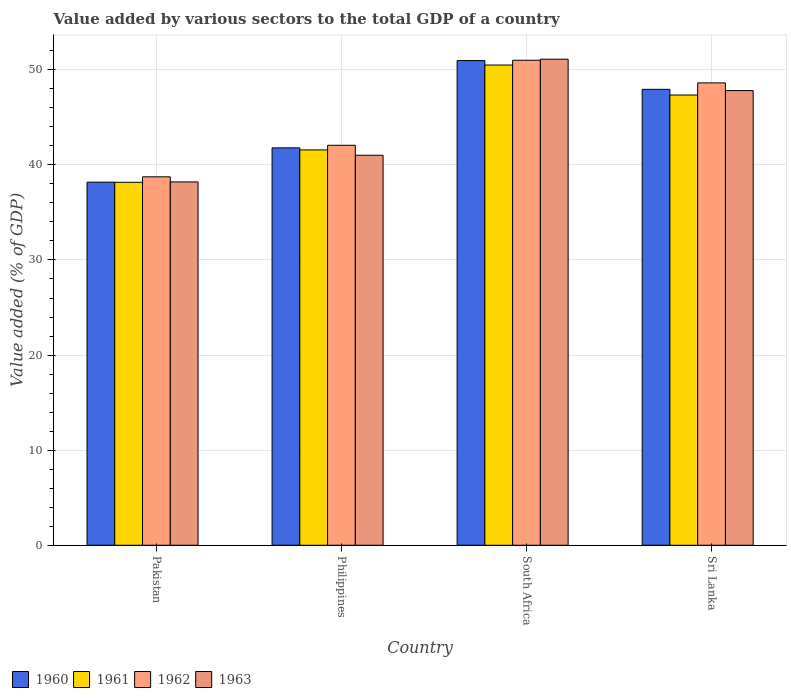How many different coloured bars are there?
Offer a very short reply. 4. Are the number of bars per tick equal to the number of legend labels?
Provide a succinct answer. Yes. Are the number of bars on each tick of the X-axis equal?
Keep it short and to the point. Yes. How many bars are there on the 1st tick from the right?
Provide a succinct answer. 4. What is the label of the 1st group of bars from the left?
Give a very brief answer. Pakistan. What is the value added by various sectors to the total GDP in 1961 in Sri Lanka?
Your response must be concise. 47.35. Across all countries, what is the maximum value added by various sectors to the total GDP in 1963?
Offer a very short reply. 51.12. Across all countries, what is the minimum value added by various sectors to the total GDP in 1960?
Ensure brevity in your answer.  38.18. In which country was the value added by various sectors to the total GDP in 1961 maximum?
Your answer should be compact. South Africa. In which country was the value added by various sectors to the total GDP in 1961 minimum?
Keep it short and to the point. Pakistan. What is the total value added by various sectors to the total GDP in 1962 in the graph?
Offer a very short reply. 180.44. What is the difference between the value added by various sectors to the total GDP in 1961 in South Africa and that in Sri Lanka?
Offer a terse response. 3.16. What is the difference between the value added by various sectors to the total GDP in 1962 in Philippines and the value added by various sectors to the total GDP in 1963 in Pakistan?
Ensure brevity in your answer.  3.85. What is the average value added by various sectors to the total GDP in 1962 per country?
Offer a very short reply. 45.11. What is the difference between the value added by various sectors to the total GDP of/in 1961 and value added by various sectors to the total GDP of/in 1963 in Pakistan?
Your answer should be very brief. -0.04. What is the ratio of the value added by various sectors to the total GDP in 1960 in Pakistan to that in Philippines?
Provide a short and direct response. 0.91. What is the difference between the highest and the second highest value added by various sectors to the total GDP in 1962?
Your answer should be compact. 6.56. What is the difference between the highest and the lowest value added by various sectors to the total GDP in 1963?
Offer a terse response. 12.91. In how many countries, is the value added by various sectors to the total GDP in 1962 greater than the average value added by various sectors to the total GDP in 1962 taken over all countries?
Offer a very short reply. 2. Is the sum of the value added by various sectors to the total GDP in 1960 in Pakistan and Philippines greater than the maximum value added by various sectors to the total GDP in 1963 across all countries?
Keep it short and to the point. Yes. Is it the case that in every country, the sum of the value added by various sectors to the total GDP in 1961 and value added by various sectors to the total GDP in 1963 is greater than the sum of value added by various sectors to the total GDP in 1960 and value added by various sectors to the total GDP in 1962?
Make the answer very short. No. What does the 4th bar from the right in Philippines represents?
Your response must be concise. 1960. Are all the bars in the graph horizontal?
Your answer should be very brief. No. What is the difference between two consecutive major ticks on the Y-axis?
Make the answer very short. 10. Does the graph contain any zero values?
Provide a short and direct response. No. How many legend labels are there?
Your response must be concise. 4. How are the legend labels stacked?
Make the answer very short. Horizontal. What is the title of the graph?
Keep it short and to the point. Value added by various sectors to the total GDP of a country. Does "1968" appear as one of the legend labels in the graph?
Give a very brief answer. No. What is the label or title of the X-axis?
Offer a very short reply. Country. What is the label or title of the Y-axis?
Make the answer very short. Value added (% of GDP). What is the Value added (% of GDP) in 1960 in Pakistan?
Keep it short and to the point. 38.18. What is the Value added (% of GDP) of 1961 in Pakistan?
Provide a short and direct response. 38.17. What is the Value added (% of GDP) of 1962 in Pakistan?
Offer a terse response. 38.74. What is the Value added (% of GDP) of 1963 in Pakistan?
Offer a terse response. 38.21. What is the Value added (% of GDP) in 1960 in Philippines?
Provide a succinct answer. 41.79. What is the Value added (% of GDP) in 1961 in Philippines?
Provide a succinct answer. 41.57. What is the Value added (% of GDP) in 1962 in Philippines?
Ensure brevity in your answer.  42.06. What is the Value added (% of GDP) of 1963 in Philippines?
Your answer should be very brief. 41.01. What is the Value added (% of GDP) in 1960 in South Africa?
Make the answer very short. 50.97. What is the Value added (% of GDP) of 1961 in South Africa?
Give a very brief answer. 50.5. What is the Value added (% of GDP) of 1962 in South Africa?
Your response must be concise. 51.01. What is the Value added (% of GDP) in 1963 in South Africa?
Provide a succinct answer. 51.12. What is the Value added (% of GDP) in 1960 in Sri Lanka?
Offer a very short reply. 47.95. What is the Value added (% of GDP) in 1961 in Sri Lanka?
Make the answer very short. 47.35. What is the Value added (% of GDP) in 1962 in Sri Lanka?
Give a very brief answer. 48.62. What is the Value added (% of GDP) in 1963 in Sri Lanka?
Your response must be concise. 47.82. Across all countries, what is the maximum Value added (% of GDP) in 1960?
Offer a terse response. 50.97. Across all countries, what is the maximum Value added (% of GDP) of 1961?
Keep it short and to the point. 50.5. Across all countries, what is the maximum Value added (% of GDP) in 1962?
Your response must be concise. 51.01. Across all countries, what is the maximum Value added (% of GDP) in 1963?
Your response must be concise. 51.12. Across all countries, what is the minimum Value added (% of GDP) in 1960?
Make the answer very short. 38.18. Across all countries, what is the minimum Value added (% of GDP) in 1961?
Offer a terse response. 38.17. Across all countries, what is the minimum Value added (% of GDP) of 1962?
Offer a very short reply. 38.74. Across all countries, what is the minimum Value added (% of GDP) in 1963?
Provide a short and direct response. 38.21. What is the total Value added (% of GDP) in 1960 in the graph?
Make the answer very short. 178.89. What is the total Value added (% of GDP) of 1961 in the graph?
Your answer should be compact. 177.59. What is the total Value added (% of GDP) of 1962 in the graph?
Ensure brevity in your answer.  180.44. What is the total Value added (% of GDP) of 1963 in the graph?
Provide a short and direct response. 178.16. What is the difference between the Value added (% of GDP) of 1960 in Pakistan and that in Philippines?
Your answer should be compact. -3.61. What is the difference between the Value added (% of GDP) of 1961 in Pakistan and that in Philippines?
Your response must be concise. -3.41. What is the difference between the Value added (% of GDP) in 1962 in Pakistan and that in Philippines?
Your response must be concise. -3.32. What is the difference between the Value added (% of GDP) in 1963 in Pakistan and that in Philippines?
Keep it short and to the point. -2.81. What is the difference between the Value added (% of GDP) of 1960 in Pakistan and that in South Africa?
Make the answer very short. -12.79. What is the difference between the Value added (% of GDP) in 1961 in Pakistan and that in South Africa?
Your answer should be compact. -12.33. What is the difference between the Value added (% of GDP) in 1962 in Pakistan and that in South Africa?
Provide a succinct answer. -12.26. What is the difference between the Value added (% of GDP) of 1963 in Pakistan and that in South Africa?
Your answer should be very brief. -12.91. What is the difference between the Value added (% of GDP) in 1960 in Pakistan and that in Sri Lanka?
Offer a very short reply. -9.76. What is the difference between the Value added (% of GDP) in 1961 in Pakistan and that in Sri Lanka?
Offer a very short reply. -9.18. What is the difference between the Value added (% of GDP) in 1962 in Pakistan and that in Sri Lanka?
Your response must be concise. -9.88. What is the difference between the Value added (% of GDP) in 1963 in Pakistan and that in Sri Lanka?
Your response must be concise. -9.61. What is the difference between the Value added (% of GDP) of 1960 in Philippines and that in South Africa?
Ensure brevity in your answer.  -9.18. What is the difference between the Value added (% of GDP) in 1961 in Philippines and that in South Africa?
Give a very brief answer. -8.93. What is the difference between the Value added (% of GDP) in 1962 in Philippines and that in South Africa?
Provide a short and direct response. -8.94. What is the difference between the Value added (% of GDP) in 1963 in Philippines and that in South Africa?
Offer a terse response. -10.1. What is the difference between the Value added (% of GDP) in 1960 in Philippines and that in Sri Lanka?
Offer a very short reply. -6.15. What is the difference between the Value added (% of GDP) of 1961 in Philippines and that in Sri Lanka?
Make the answer very short. -5.77. What is the difference between the Value added (% of GDP) in 1962 in Philippines and that in Sri Lanka?
Provide a short and direct response. -6.56. What is the difference between the Value added (% of GDP) of 1963 in Philippines and that in Sri Lanka?
Your response must be concise. -6.8. What is the difference between the Value added (% of GDP) of 1960 in South Africa and that in Sri Lanka?
Offer a terse response. 3.03. What is the difference between the Value added (% of GDP) in 1961 in South Africa and that in Sri Lanka?
Ensure brevity in your answer.  3.16. What is the difference between the Value added (% of GDP) in 1962 in South Africa and that in Sri Lanka?
Make the answer very short. 2.38. What is the difference between the Value added (% of GDP) of 1963 in South Africa and that in Sri Lanka?
Ensure brevity in your answer.  3.3. What is the difference between the Value added (% of GDP) of 1960 in Pakistan and the Value added (% of GDP) of 1961 in Philippines?
Offer a very short reply. -3.39. What is the difference between the Value added (% of GDP) of 1960 in Pakistan and the Value added (% of GDP) of 1962 in Philippines?
Give a very brief answer. -3.88. What is the difference between the Value added (% of GDP) of 1960 in Pakistan and the Value added (% of GDP) of 1963 in Philippines?
Provide a succinct answer. -2.83. What is the difference between the Value added (% of GDP) of 1961 in Pakistan and the Value added (% of GDP) of 1962 in Philippines?
Your response must be concise. -3.89. What is the difference between the Value added (% of GDP) of 1961 in Pakistan and the Value added (% of GDP) of 1963 in Philippines?
Give a very brief answer. -2.85. What is the difference between the Value added (% of GDP) of 1962 in Pakistan and the Value added (% of GDP) of 1963 in Philippines?
Ensure brevity in your answer.  -2.27. What is the difference between the Value added (% of GDP) of 1960 in Pakistan and the Value added (% of GDP) of 1961 in South Africa?
Offer a terse response. -12.32. What is the difference between the Value added (% of GDP) of 1960 in Pakistan and the Value added (% of GDP) of 1962 in South Africa?
Offer a very short reply. -12.82. What is the difference between the Value added (% of GDP) of 1960 in Pakistan and the Value added (% of GDP) of 1963 in South Africa?
Provide a succinct answer. -12.93. What is the difference between the Value added (% of GDP) of 1961 in Pakistan and the Value added (% of GDP) of 1962 in South Africa?
Ensure brevity in your answer.  -12.84. What is the difference between the Value added (% of GDP) of 1961 in Pakistan and the Value added (% of GDP) of 1963 in South Africa?
Keep it short and to the point. -12.95. What is the difference between the Value added (% of GDP) in 1962 in Pakistan and the Value added (% of GDP) in 1963 in South Africa?
Your response must be concise. -12.37. What is the difference between the Value added (% of GDP) in 1960 in Pakistan and the Value added (% of GDP) in 1961 in Sri Lanka?
Provide a short and direct response. -9.16. What is the difference between the Value added (% of GDP) in 1960 in Pakistan and the Value added (% of GDP) in 1962 in Sri Lanka?
Provide a succinct answer. -10.44. What is the difference between the Value added (% of GDP) of 1960 in Pakistan and the Value added (% of GDP) of 1963 in Sri Lanka?
Your answer should be compact. -9.63. What is the difference between the Value added (% of GDP) of 1961 in Pakistan and the Value added (% of GDP) of 1962 in Sri Lanka?
Offer a very short reply. -10.46. What is the difference between the Value added (% of GDP) of 1961 in Pakistan and the Value added (% of GDP) of 1963 in Sri Lanka?
Your answer should be very brief. -9.65. What is the difference between the Value added (% of GDP) of 1962 in Pakistan and the Value added (% of GDP) of 1963 in Sri Lanka?
Your response must be concise. -9.07. What is the difference between the Value added (% of GDP) in 1960 in Philippines and the Value added (% of GDP) in 1961 in South Africa?
Your answer should be compact. -8.71. What is the difference between the Value added (% of GDP) of 1960 in Philippines and the Value added (% of GDP) of 1962 in South Africa?
Offer a terse response. -9.21. What is the difference between the Value added (% of GDP) in 1960 in Philippines and the Value added (% of GDP) in 1963 in South Africa?
Provide a succinct answer. -9.33. What is the difference between the Value added (% of GDP) of 1961 in Philippines and the Value added (% of GDP) of 1962 in South Africa?
Offer a terse response. -9.43. What is the difference between the Value added (% of GDP) in 1961 in Philippines and the Value added (% of GDP) in 1963 in South Africa?
Give a very brief answer. -9.54. What is the difference between the Value added (% of GDP) in 1962 in Philippines and the Value added (% of GDP) in 1963 in South Africa?
Make the answer very short. -9.05. What is the difference between the Value added (% of GDP) in 1960 in Philippines and the Value added (% of GDP) in 1961 in Sri Lanka?
Make the answer very short. -5.55. What is the difference between the Value added (% of GDP) in 1960 in Philippines and the Value added (% of GDP) in 1962 in Sri Lanka?
Provide a succinct answer. -6.83. What is the difference between the Value added (% of GDP) of 1960 in Philippines and the Value added (% of GDP) of 1963 in Sri Lanka?
Your answer should be very brief. -6.03. What is the difference between the Value added (% of GDP) of 1961 in Philippines and the Value added (% of GDP) of 1962 in Sri Lanka?
Give a very brief answer. -7.05. What is the difference between the Value added (% of GDP) of 1961 in Philippines and the Value added (% of GDP) of 1963 in Sri Lanka?
Your answer should be compact. -6.24. What is the difference between the Value added (% of GDP) in 1962 in Philippines and the Value added (% of GDP) in 1963 in Sri Lanka?
Your answer should be compact. -5.75. What is the difference between the Value added (% of GDP) in 1960 in South Africa and the Value added (% of GDP) in 1961 in Sri Lanka?
Make the answer very short. 3.63. What is the difference between the Value added (% of GDP) of 1960 in South Africa and the Value added (% of GDP) of 1962 in Sri Lanka?
Offer a very short reply. 2.35. What is the difference between the Value added (% of GDP) in 1960 in South Africa and the Value added (% of GDP) in 1963 in Sri Lanka?
Provide a short and direct response. 3.16. What is the difference between the Value added (% of GDP) of 1961 in South Africa and the Value added (% of GDP) of 1962 in Sri Lanka?
Ensure brevity in your answer.  1.88. What is the difference between the Value added (% of GDP) of 1961 in South Africa and the Value added (% of GDP) of 1963 in Sri Lanka?
Your answer should be very brief. 2.69. What is the difference between the Value added (% of GDP) of 1962 in South Africa and the Value added (% of GDP) of 1963 in Sri Lanka?
Your answer should be very brief. 3.19. What is the average Value added (% of GDP) of 1960 per country?
Your answer should be compact. 44.72. What is the average Value added (% of GDP) of 1961 per country?
Offer a terse response. 44.4. What is the average Value added (% of GDP) of 1962 per country?
Your response must be concise. 45.11. What is the average Value added (% of GDP) in 1963 per country?
Give a very brief answer. 44.54. What is the difference between the Value added (% of GDP) of 1960 and Value added (% of GDP) of 1961 in Pakistan?
Your response must be concise. 0.01. What is the difference between the Value added (% of GDP) of 1960 and Value added (% of GDP) of 1962 in Pakistan?
Give a very brief answer. -0.56. What is the difference between the Value added (% of GDP) in 1960 and Value added (% of GDP) in 1963 in Pakistan?
Your response must be concise. -0.03. What is the difference between the Value added (% of GDP) in 1961 and Value added (% of GDP) in 1962 in Pakistan?
Your response must be concise. -0.58. What is the difference between the Value added (% of GDP) in 1961 and Value added (% of GDP) in 1963 in Pakistan?
Offer a terse response. -0.04. What is the difference between the Value added (% of GDP) in 1962 and Value added (% of GDP) in 1963 in Pakistan?
Offer a terse response. 0.53. What is the difference between the Value added (% of GDP) in 1960 and Value added (% of GDP) in 1961 in Philippines?
Your response must be concise. 0.22. What is the difference between the Value added (% of GDP) of 1960 and Value added (% of GDP) of 1962 in Philippines?
Your response must be concise. -0.27. What is the difference between the Value added (% of GDP) of 1960 and Value added (% of GDP) of 1963 in Philippines?
Your answer should be very brief. 0.78. What is the difference between the Value added (% of GDP) of 1961 and Value added (% of GDP) of 1962 in Philippines?
Provide a short and direct response. -0.49. What is the difference between the Value added (% of GDP) in 1961 and Value added (% of GDP) in 1963 in Philippines?
Your response must be concise. 0.56. What is the difference between the Value added (% of GDP) in 1962 and Value added (% of GDP) in 1963 in Philippines?
Make the answer very short. 1.05. What is the difference between the Value added (% of GDP) of 1960 and Value added (% of GDP) of 1961 in South Africa?
Your answer should be very brief. 0.47. What is the difference between the Value added (% of GDP) of 1960 and Value added (% of GDP) of 1962 in South Africa?
Keep it short and to the point. -0.03. What is the difference between the Value added (% of GDP) in 1960 and Value added (% of GDP) in 1963 in South Africa?
Make the answer very short. -0.15. What is the difference between the Value added (% of GDP) of 1961 and Value added (% of GDP) of 1962 in South Africa?
Make the answer very short. -0.5. What is the difference between the Value added (% of GDP) in 1961 and Value added (% of GDP) in 1963 in South Africa?
Your response must be concise. -0.61. What is the difference between the Value added (% of GDP) in 1962 and Value added (% of GDP) in 1963 in South Africa?
Your answer should be very brief. -0.11. What is the difference between the Value added (% of GDP) in 1960 and Value added (% of GDP) in 1961 in Sri Lanka?
Your answer should be compact. 0.6. What is the difference between the Value added (% of GDP) of 1960 and Value added (% of GDP) of 1962 in Sri Lanka?
Your answer should be very brief. -0.68. What is the difference between the Value added (% of GDP) in 1960 and Value added (% of GDP) in 1963 in Sri Lanka?
Provide a succinct answer. 0.13. What is the difference between the Value added (% of GDP) in 1961 and Value added (% of GDP) in 1962 in Sri Lanka?
Your answer should be compact. -1.28. What is the difference between the Value added (% of GDP) in 1961 and Value added (% of GDP) in 1963 in Sri Lanka?
Your answer should be compact. -0.47. What is the difference between the Value added (% of GDP) in 1962 and Value added (% of GDP) in 1963 in Sri Lanka?
Ensure brevity in your answer.  0.81. What is the ratio of the Value added (% of GDP) in 1960 in Pakistan to that in Philippines?
Make the answer very short. 0.91. What is the ratio of the Value added (% of GDP) in 1961 in Pakistan to that in Philippines?
Your response must be concise. 0.92. What is the ratio of the Value added (% of GDP) of 1962 in Pakistan to that in Philippines?
Your answer should be very brief. 0.92. What is the ratio of the Value added (% of GDP) of 1963 in Pakistan to that in Philippines?
Provide a succinct answer. 0.93. What is the ratio of the Value added (% of GDP) of 1960 in Pakistan to that in South Africa?
Your answer should be very brief. 0.75. What is the ratio of the Value added (% of GDP) in 1961 in Pakistan to that in South Africa?
Provide a succinct answer. 0.76. What is the ratio of the Value added (% of GDP) in 1962 in Pakistan to that in South Africa?
Keep it short and to the point. 0.76. What is the ratio of the Value added (% of GDP) in 1963 in Pakistan to that in South Africa?
Give a very brief answer. 0.75. What is the ratio of the Value added (% of GDP) in 1960 in Pakistan to that in Sri Lanka?
Your answer should be compact. 0.8. What is the ratio of the Value added (% of GDP) in 1961 in Pakistan to that in Sri Lanka?
Make the answer very short. 0.81. What is the ratio of the Value added (% of GDP) of 1962 in Pakistan to that in Sri Lanka?
Your answer should be compact. 0.8. What is the ratio of the Value added (% of GDP) of 1963 in Pakistan to that in Sri Lanka?
Your answer should be compact. 0.8. What is the ratio of the Value added (% of GDP) of 1960 in Philippines to that in South Africa?
Your response must be concise. 0.82. What is the ratio of the Value added (% of GDP) of 1961 in Philippines to that in South Africa?
Your answer should be compact. 0.82. What is the ratio of the Value added (% of GDP) in 1962 in Philippines to that in South Africa?
Give a very brief answer. 0.82. What is the ratio of the Value added (% of GDP) of 1963 in Philippines to that in South Africa?
Your answer should be compact. 0.8. What is the ratio of the Value added (% of GDP) in 1960 in Philippines to that in Sri Lanka?
Make the answer very short. 0.87. What is the ratio of the Value added (% of GDP) in 1961 in Philippines to that in Sri Lanka?
Offer a terse response. 0.88. What is the ratio of the Value added (% of GDP) of 1962 in Philippines to that in Sri Lanka?
Your response must be concise. 0.87. What is the ratio of the Value added (% of GDP) of 1963 in Philippines to that in Sri Lanka?
Provide a succinct answer. 0.86. What is the ratio of the Value added (% of GDP) in 1960 in South Africa to that in Sri Lanka?
Your answer should be compact. 1.06. What is the ratio of the Value added (% of GDP) in 1961 in South Africa to that in Sri Lanka?
Provide a succinct answer. 1.07. What is the ratio of the Value added (% of GDP) in 1962 in South Africa to that in Sri Lanka?
Your answer should be compact. 1.05. What is the ratio of the Value added (% of GDP) of 1963 in South Africa to that in Sri Lanka?
Keep it short and to the point. 1.07. What is the difference between the highest and the second highest Value added (% of GDP) of 1960?
Your answer should be very brief. 3.03. What is the difference between the highest and the second highest Value added (% of GDP) in 1961?
Offer a terse response. 3.16. What is the difference between the highest and the second highest Value added (% of GDP) in 1962?
Your answer should be compact. 2.38. What is the difference between the highest and the second highest Value added (% of GDP) in 1963?
Your response must be concise. 3.3. What is the difference between the highest and the lowest Value added (% of GDP) of 1960?
Ensure brevity in your answer.  12.79. What is the difference between the highest and the lowest Value added (% of GDP) of 1961?
Provide a short and direct response. 12.33. What is the difference between the highest and the lowest Value added (% of GDP) of 1962?
Make the answer very short. 12.26. What is the difference between the highest and the lowest Value added (% of GDP) in 1963?
Offer a very short reply. 12.91. 